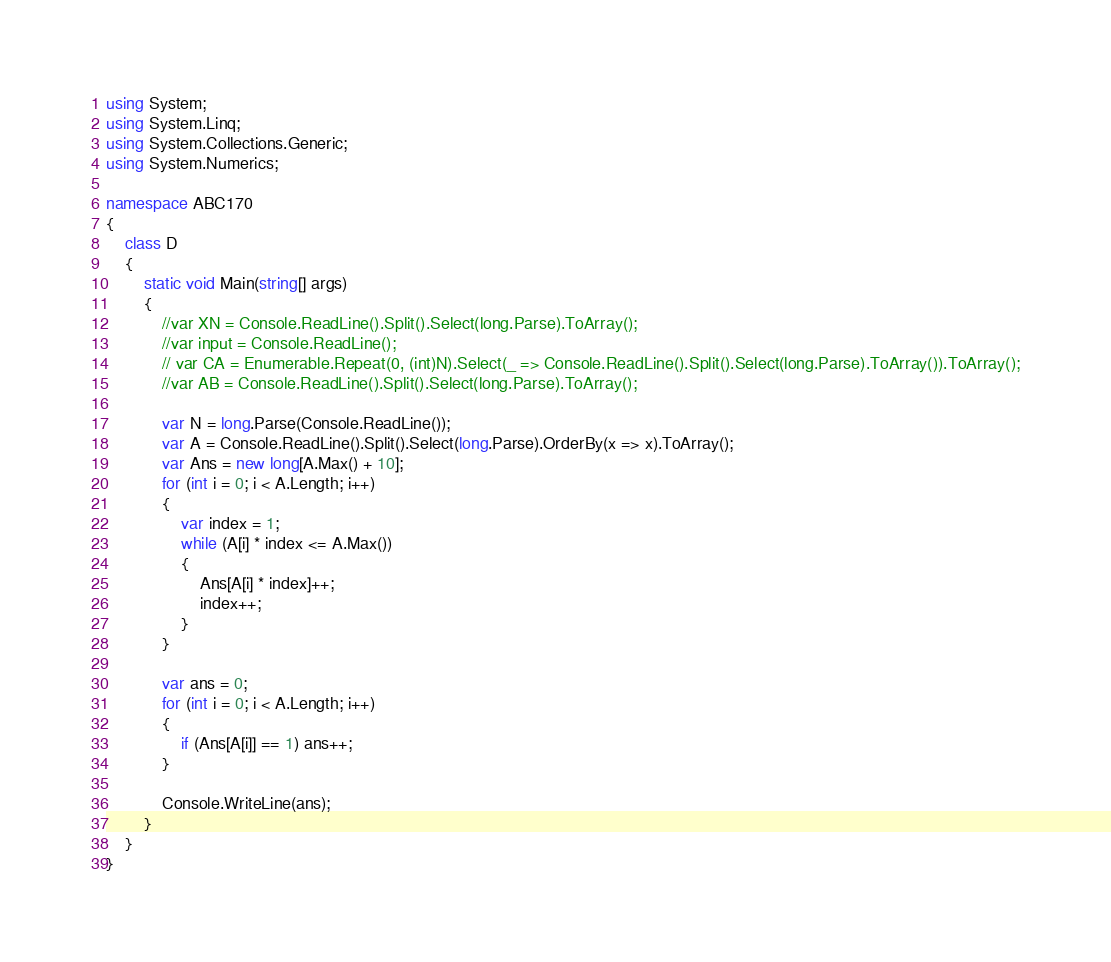<code> <loc_0><loc_0><loc_500><loc_500><_C#_>using System;
using System.Linq;
using System.Collections.Generic;
using System.Numerics;

namespace ABC170
{
    class D
    {
        static void Main(string[] args)
        {
            //var XN = Console.ReadLine().Split().Select(long.Parse).ToArray();
            //var input = Console.ReadLine();
            // var CA = Enumerable.Repeat(0, (int)N).Select(_ => Console.ReadLine().Split().Select(long.Parse).ToArray()).ToArray();
            //var AB = Console.ReadLine().Split().Select(long.Parse).ToArray();

            var N = long.Parse(Console.ReadLine());
            var A = Console.ReadLine().Split().Select(long.Parse).OrderBy(x => x).ToArray();
            var Ans = new long[A.Max() + 10];
            for (int i = 0; i < A.Length; i++)
            {
                var index = 1;
                while (A[i] * index <= A.Max())
                {
                    Ans[A[i] * index]++;
                    index++;
                }
            }

            var ans = 0;
            for (int i = 0; i < A.Length; i++)
            {
                if (Ans[A[i]] == 1) ans++;
            }

            Console.WriteLine(ans);
        }
    }
}</code> 